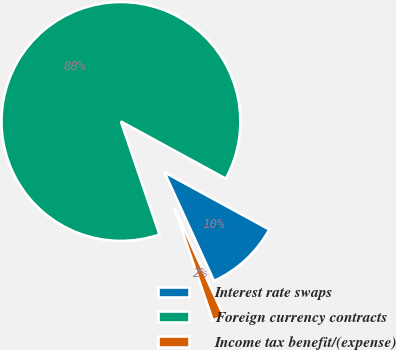Convert chart. <chart><loc_0><loc_0><loc_500><loc_500><pie_chart><fcel>Interest rate swaps<fcel>Foreign currency contracts<fcel>Income tax benefit/(expense)<nl><fcel>10.24%<fcel>88.19%<fcel>1.57%<nl></chart> 